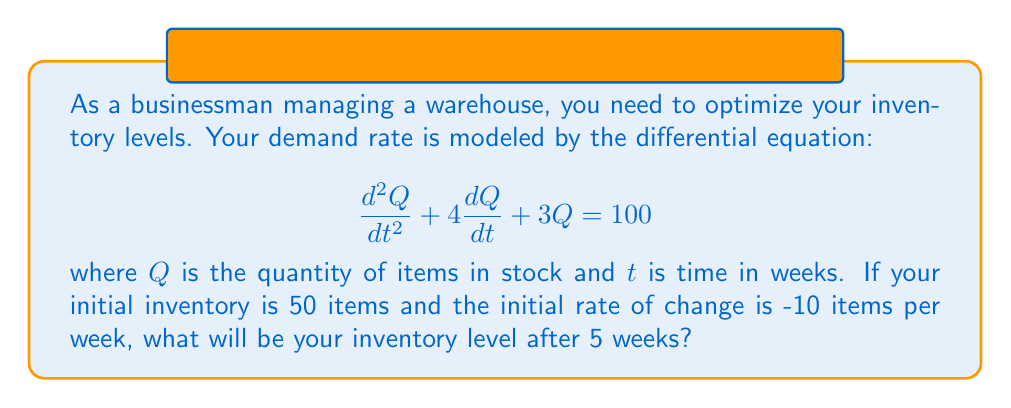Help me with this question. To solve this problem, we need to follow these steps:

1) First, we recognize this as a second-order linear differential equation with constant coefficients. The general solution has the form:

   $$Q(t) = Q_h(t) + Q_p(t)$$

   where $Q_h(t)$ is the homogeneous solution and $Q_p(t)$ is the particular solution.

2) For the homogeneous part, we solve the characteristic equation:

   $$r^2 + 4r + 3 = 0$$

   This gives us $r_1 = -1$ and $r_2 = -3$. So, the homogeneous solution is:

   $$Q_h(t) = c_1e^{-t} + c_2e^{-3t}$$

3) For the particular solution, since the right side is a constant, we guess:

   $$Q_p(t) = A$$

   Substituting this into the original equation:

   $$0 + 0 + 3A = 100$$
   $$A = \frac{100}{3}$$

4) So, the general solution is:

   $$Q(t) = c_1e^{-t} + c_2e^{-3t} + \frac{100}{3}$$

5) Now we use the initial conditions to find $c_1$ and $c_2$:

   At $t=0$, $Q(0) = 50$:
   $$50 = c_1 + c_2 + \frac{100}{3}$$

   Also, $Q'(t) = -c_1e^{-t} - 3c_2e^{-3t}$, so at $t=0$, $Q'(0) = -10$:
   $$-10 = -c_1 - 3c_2$$

6) Solving these equations:

   $$c_1 = 40, c_2 = -\frac{50}{3}$$

7) Therefore, the particular solution for our problem is:

   $$Q(t) = 40e^{-t} - \frac{50}{3}e^{-3t} + \frac{100}{3}$$

8) To find the inventory level after 5 weeks, we evaluate $Q(5)$:

   $$Q(5) = 40e^{-5} - \frac{50}{3}e^{-15} + \frac{100}{3}$$

9) Calculating this (you may use a calculator):

   $$Q(5) \approx 33.90$$
Answer: The inventory level after 5 weeks will be approximately 33.90 items. 